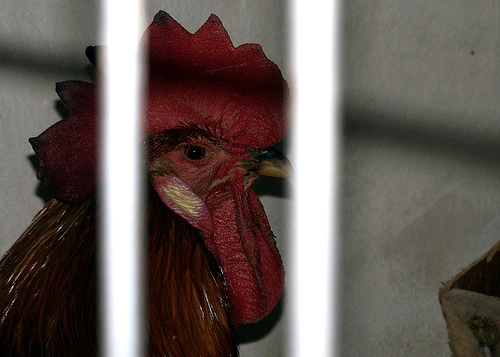<image>
Is there a bird in front of the bar? No. The bird is not in front of the bar. The spatial positioning shows a different relationship between these objects. 